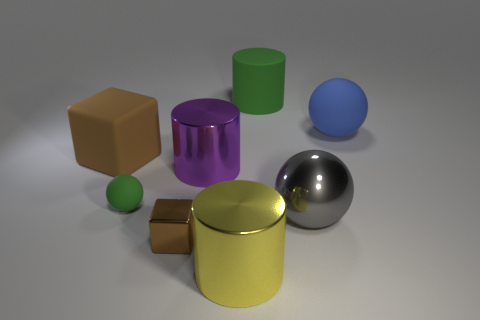The cylinder that is left of the yellow shiny thing is what color?
Offer a terse response. Purple. There is a purple thing that is the same shape as the large yellow shiny object; what is its size?
Provide a short and direct response. Large. How many objects are either green matte objects that are right of the big purple metal cylinder or matte objects behind the blue matte ball?
Offer a terse response. 1. There is a object that is both in front of the big blue rubber sphere and behind the purple cylinder; how big is it?
Give a very brief answer. Large. There is a small brown metallic object; does it have the same shape as the thing that is on the right side of the gray object?
Keep it short and to the point. No. How many things are rubber objects in front of the big rubber sphere or big green rubber cubes?
Offer a terse response. 2. Are the small cube and the large sphere in front of the large matte sphere made of the same material?
Provide a short and direct response. Yes. The rubber object in front of the brown cube that is behind the large gray sphere is what shape?
Offer a very short reply. Sphere. Do the rubber block and the large cylinder that is in front of the big gray thing have the same color?
Your answer should be compact. No. Is there anything else that has the same material as the yellow cylinder?
Ensure brevity in your answer.  Yes. 